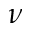Convert formula to latex. <formula><loc_0><loc_0><loc_500><loc_500>\nu</formula> 